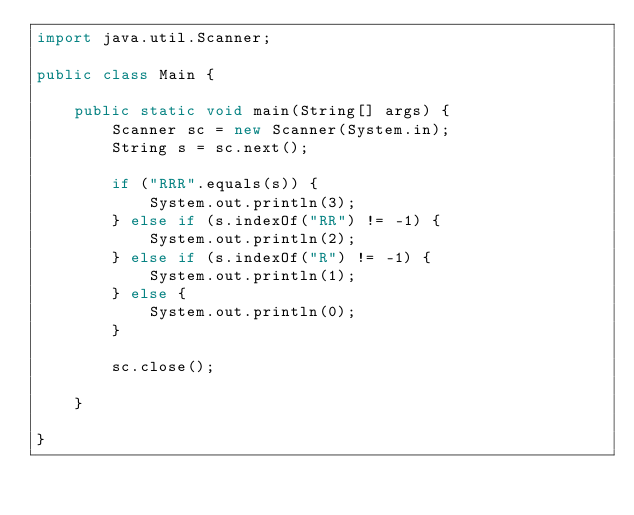<code> <loc_0><loc_0><loc_500><loc_500><_Java_>import java.util.Scanner;

public class Main {

	public static void main(String[] args) {
		Scanner sc = new Scanner(System.in);
		String s = sc.next();

		if ("RRR".equals(s)) {
			System.out.println(3);
		} else if (s.indexOf("RR") != -1) {
			System.out.println(2);
		} else if (s.indexOf("R") != -1) {
			System.out.println(1);
		} else {
			System.out.println(0);
		}

		sc.close();

	}

}</code> 